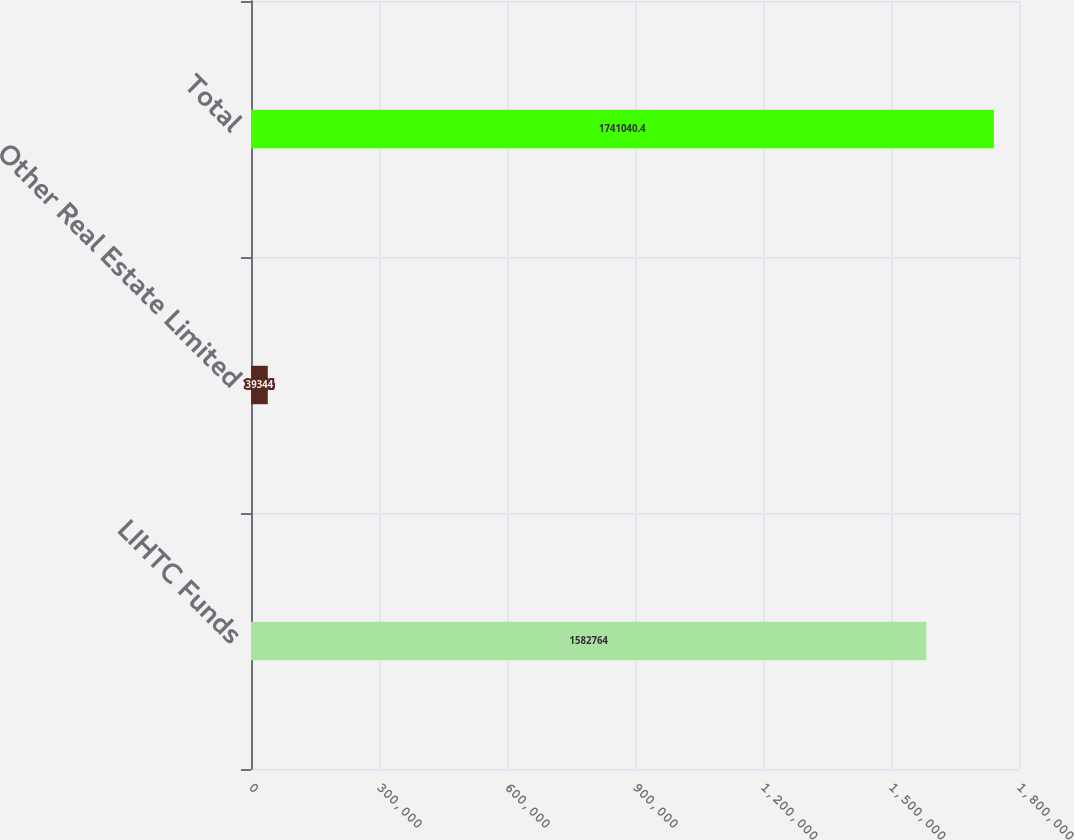<chart> <loc_0><loc_0><loc_500><loc_500><bar_chart><fcel>LIHTC Funds<fcel>Other Real Estate Limited<fcel>Total<nl><fcel>1.58276e+06<fcel>39344<fcel>1.74104e+06<nl></chart> 